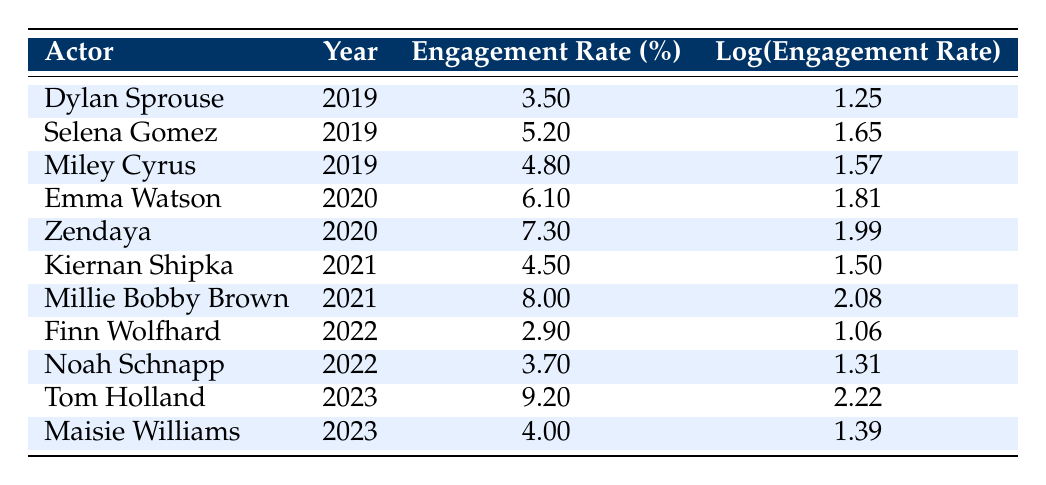What was the engagement rate of Dylan Sprouse in 2019? Dylan Sprouse's engagement rate is listed directly in the table, under the year 2019, which shows a value of 3.5.
Answer: 3.5 Which actor had the highest engagement rate in 2023? The table shows Tom Holland's engagement rate in 2023 as 9.2, which is higher than Maisie Williams's rate of 4.0. Therefore, Tom Holland had the highest engagement rate in 2023.
Answer: Tom Holland What is the average engagement rate for the years 2020 and 2021 combined? To find the average, first identify the engagement rates for 2020 (6.1 and 7.3) and 2021 (4.5 and 8.0). The sums are 6.1 + 7.3 + 4.5 + 8.0 = 26.0. There are 4 data points, so the average engagement rate is 26.0 / 4 = 6.5.
Answer: 6.5 Did any actors have an engagement rate of less than 3% during the five-year period? Examining the table, the lowest engagement rate is 2.9 for Finn Wolfhard in 2022, which is indeed below 3%. Therefore, the answer is yes.
Answer: Yes Who had a higher engagement rate in 2021, Kiernan Shipka or Millie Bobby Brown? In 2021, Kiernan Shipka had an engagement rate of 4.5 while Millie Bobby Brown had an engagement rate of 8.0. Since 8.0 is greater than 4.5, Millie Bobby Brown had the higher engagement rate.
Answer: Millie Bobby Brown What was the overall trend in engagement rates from 2019 to 2023? To understand the trend, observe the engagement rates from 2019 (3.5), 2020 (6.1, 7.3), 2021 (4.5, 8.0), 2022 (2.9, 3.7), and 2023 (9.2, 4.0). Starting low, rates peaked in 2023 predominantly, suggesting an upward trend overall despite fluctuations.
Answer: Upward trend overall How many actors had engagement rates above 5% in 2020? The table indicates Zendaya (7.3) and Emma Watson (6.1) had engagement rates above 5% in the year 2020. Therefore, there are 2 actors meeting this criterion.
Answer: 2 Was the log engagement rate for Millie Bobby Brown higher than that for Emma Watson? The log engagement rate for Millie Bobby Brown in 2021 is 2.08, whereas Emma Watson's log engagement rate in 2020 is 1.81. Since 2.08 is greater than 1.81, Millie Bobby Brown's log engagement rate is higher.
Answer: Yes What was the difference in engagement rates between Tom Holland and Finn Wolfhard? Tom Holland's engagement rate is 9.2, while Finn Wolfhard's is 2.9. The difference is calculated as 9.2 - 2.9 = 6.3, indicating that Tom Holland had a significantly higher rate.
Answer: 6.3 